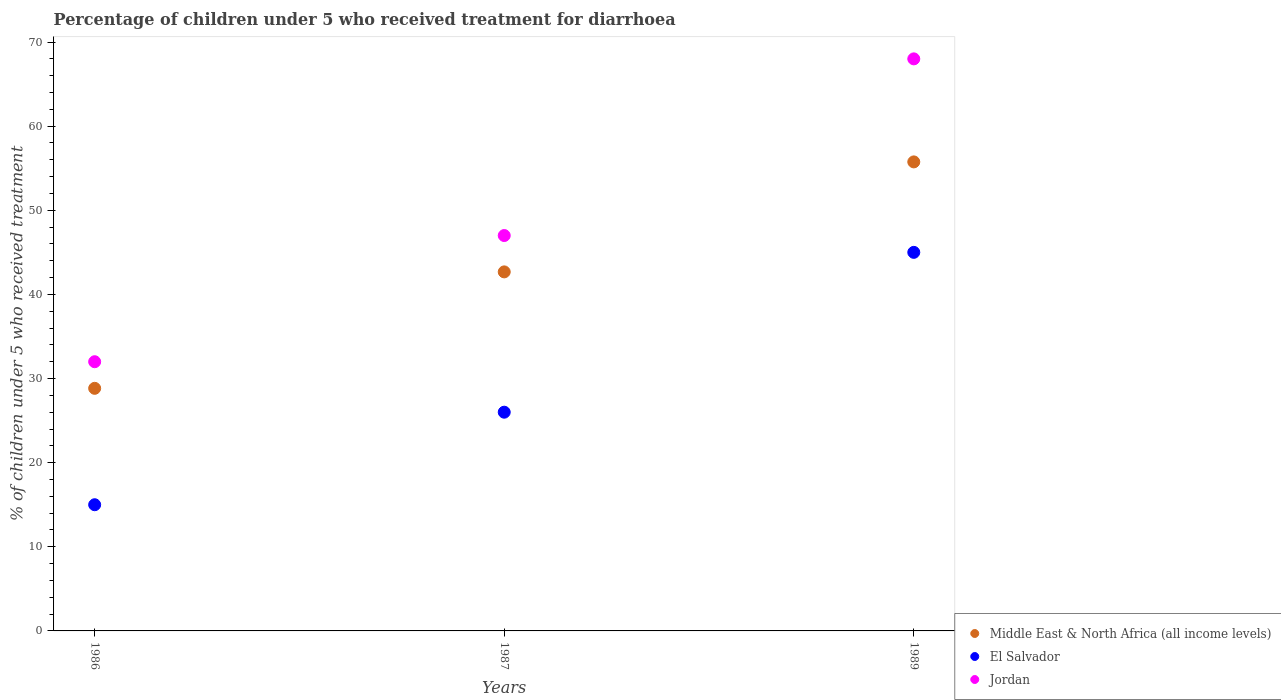What is the percentage of children who received treatment for diarrhoea  in Jordan in 1987?
Ensure brevity in your answer.  47. Across all years, what is the maximum percentage of children who received treatment for diarrhoea  in Jordan?
Your response must be concise. 68. Across all years, what is the minimum percentage of children who received treatment for diarrhoea  in Middle East & North Africa (all income levels)?
Ensure brevity in your answer.  28.84. In which year was the percentage of children who received treatment for diarrhoea  in Middle East & North Africa (all income levels) minimum?
Provide a short and direct response. 1986. What is the total percentage of children who received treatment for diarrhoea  in Middle East & North Africa (all income levels) in the graph?
Keep it short and to the point. 127.27. What is the difference between the percentage of children who received treatment for diarrhoea  in Middle East & North Africa (all income levels) in 1987 and that in 1989?
Provide a succinct answer. -13.07. What is the average percentage of children who received treatment for diarrhoea  in El Salvador per year?
Give a very brief answer. 28.67. In the year 1987, what is the difference between the percentage of children who received treatment for diarrhoea  in El Salvador and percentage of children who received treatment for diarrhoea  in Jordan?
Give a very brief answer. -21. What is the ratio of the percentage of children who received treatment for diarrhoea  in Middle East & North Africa (all income levels) in 1987 to that in 1989?
Your answer should be compact. 0.77. What is the difference between the highest and the second highest percentage of children who received treatment for diarrhoea  in Middle East & North Africa (all income levels)?
Your answer should be very brief. 13.07. What is the difference between the highest and the lowest percentage of children who received treatment for diarrhoea  in Middle East & North Africa (all income levels)?
Give a very brief answer. 26.92. In how many years, is the percentage of children who received treatment for diarrhoea  in El Salvador greater than the average percentage of children who received treatment for diarrhoea  in El Salvador taken over all years?
Your answer should be very brief. 1. Is it the case that in every year, the sum of the percentage of children who received treatment for diarrhoea  in Middle East & North Africa (all income levels) and percentage of children who received treatment for diarrhoea  in El Salvador  is greater than the percentage of children who received treatment for diarrhoea  in Jordan?
Ensure brevity in your answer.  Yes. Does the percentage of children who received treatment for diarrhoea  in Middle East & North Africa (all income levels) monotonically increase over the years?
Your answer should be compact. Yes. Is the percentage of children who received treatment for diarrhoea  in Jordan strictly greater than the percentage of children who received treatment for diarrhoea  in Middle East & North Africa (all income levels) over the years?
Your answer should be compact. Yes. Is the percentage of children who received treatment for diarrhoea  in El Salvador strictly less than the percentage of children who received treatment for diarrhoea  in Jordan over the years?
Offer a very short reply. Yes. Are the values on the major ticks of Y-axis written in scientific E-notation?
Your response must be concise. No. Does the graph contain any zero values?
Provide a short and direct response. No. How many legend labels are there?
Make the answer very short. 3. How are the legend labels stacked?
Provide a short and direct response. Vertical. What is the title of the graph?
Your answer should be very brief. Percentage of children under 5 who received treatment for diarrhoea. What is the label or title of the X-axis?
Offer a very short reply. Years. What is the label or title of the Y-axis?
Offer a terse response. % of children under 5 who received treatment. What is the % of children under 5 who received treatment of Middle East & North Africa (all income levels) in 1986?
Provide a short and direct response. 28.84. What is the % of children under 5 who received treatment in El Salvador in 1986?
Offer a very short reply. 15. What is the % of children under 5 who received treatment of Jordan in 1986?
Provide a succinct answer. 32. What is the % of children under 5 who received treatment of Middle East & North Africa (all income levels) in 1987?
Offer a very short reply. 42.68. What is the % of children under 5 who received treatment of El Salvador in 1987?
Your response must be concise. 26. What is the % of children under 5 who received treatment in Jordan in 1987?
Offer a very short reply. 47. What is the % of children under 5 who received treatment in Middle East & North Africa (all income levels) in 1989?
Offer a very short reply. 55.75. What is the % of children under 5 who received treatment of El Salvador in 1989?
Provide a succinct answer. 45. What is the % of children under 5 who received treatment of Jordan in 1989?
Make the answer very short. 68. Across all years, what is the maximum % of children under 5 who received treatment of Middle East & North Africa (all income levels)?
Your answer should be very brief. 55.75. Across all years, what is the maximum % of children under 5 who received treatment in Jordan?
Offer a very short reply. 68. Across all years, what is the minimum % of children under 5 who received treatment in Middle East & North Africa (all income levels)?
Keep it short and to the point. 28.84. Across all years, what is the minimum % of children under 5 who received treatment of El Salvador?
Ensure brevity in your answer.  15. Across all years, what is the minimum % of children under 5 who received treatment in Jordan?
Offer a very short reply. 32. What is the total % of children under 5 who received treatment of Middle East & North Africa (all income levels) in the graph?
Provide a succinct answer. 127.27. What is the total % of children under 5 who received treatment in Jordan in the graph?
Give a very brief answer. 147. What is the difference between the % of children under 5 who received treatment in Middle East & North Africa (all income levels) in 1986 and that in 1987?
Your answer should be very brief. -13.84. What is the difference between the % of children under 5 who received treatment in El Salvador in 1986 and that in 1987?
Offer a terse response. -11. What is the difference between the % of children under 5 who received treatment in Middle East & North Africa (all income levels) in 1986 and that in 1989?
Your response must be concise. -26.92. What is the difference between the % of children under 5 who received treatment in Jordan in 1986 and that in 1989?
Your answer should be compact. -36. What is the difference between the % of children under 5 who received treatment in Middle East & North Africa (all income levels) in 1987 and that in 1989?
Make the answer very short. -13.07. What is the difference between the % of children under 5 who received treatment in El Salvador in 1987 and that in 1989?
Keep it short and to the point. -19. What is the difference between the % of children under 5 who received treatment of Middle East & North Africa (all income levels) in 1986 and the % of children under 5 who received treatment of El Salvador in 1987?
Offer a terse response. 2.84. What is the difference between the % of children under 5 who received treatment in Middle East & North Africa (all income levels) in 1986 and the % of children under 5 who received treatment in Jordan in 1987?
Your response must be concise. -18.16. What is the difference between the % of children under 5 who received treatment of El Salvador in 1986 and the % of children under 5 who received treatment of Jordan in 1987?
Ensure brevity in your answer.  -32. What is the difference between the % of children under 5 who received treatment of Middle East & North Africa (all income levels) in 1986 and the % of children under 5 who received treatment of El Salvador in 1989?
Your answer should be very brief. -16.16. What is the difference between the % of children under 5 who received treatment in Middle East & North Africa (all income levels) in 1986 and the % of children under 5 who received treatment in Jordan in 1989?
Ensure brevity in your answer.  -39.16. What is the difference between the % of children under 5 who received treatment of El Salvador in 1986 and the % of children under 5 who received treatment of Jordan in 1989?
Provide a succinct answer. -53. What is the difference between the % of children under 5 who received treatment in Middle East & North Africa (all income levels) in 1987 and the % of children under 5 who received treatment in El Salvador in 1989?
Offer a very short reply. -2.32. What is the difference between the % of children under 5 who received treatment of Middle East & North Africa (all income levels) in 1987 and the % of children under 5 who received treatment of Jordan in 1989?
Make the answer very short. -25.32. What is the difference between the % of children under 5 who received treatment in El Salvador in 1987 and the % of children under 5 who received treatment in Jordan in 1989?
Keep it short and to the point. -42. What is the average % of children under 5 who received treatment of Middle East & North Africa (all income levels) per year?
Make the answer very short. 42.42. What is the average % of children under 5 who received treatment in El Salvador per year?
Give a very brief answer. 28.67. What is the average % of children under 5 who received treatment of Jordan per year?
Give a very brief answer. 49. In the year 1986, what is the difference between the % of children under 5 who received treatment in Middle East & North Africa (all income levels) and % of children under 5 who received treatment in El Salvador?
Offer a very short reply. 13.84. In the year 1986, what is the difference between the % of children under 5 who received treatment of Middle East & North Africa (all income levels) and % of children under 5 who received treatment of Jordan?
Your answer should be compact. -3.16. In the year 1987, what is the difference between the % of children under 5 who received treatment in Middle East & North Africa (all income levels) and % of children under 5 who received treatment in El Salvador?
Make the answer very short. 16.68. In the year 1987, what is the difference between the % of children under 5 who received treatment of Middle East & North Africa (all income levels) and % of children under 5 who received treatment of Jordan?
Your response must be concise. -4.32. In the year 1987, what is the difference between the % of children under 5 who received treatment in El Salvador and % of children under 5 who received treatment in Jordan?
Keep it short and to the point. -21. In the year 1989, what is the difference between the % of children under 5 who received treatment of Middle East & North Africa (all income levels) and % of children under 5 who received treatment of El Salvador?
Make the answer very short. 10.75. In the year 1989, what is the difference between the % of children under 5 who received treatment of Middle East & North Africa (all income levels) and % of children under 5 who received treatment of Jordan?
Provide a succinct answer. -12.25. What is the ratio of the % of children under 5 who received treatment of Middle East & North Africa (all income levels) in 1986 to that in 1987?
Ensure brevity in your answer.  0.68. What is the ratio of the % of children under 5 who received treatment of El Salvador in 1986 to that in 1987?
Your response must be concise. 0.58. What is the ratio of the % of children under 5 who received treatment in Jordan in 1986 to that in 1987?
Your response must be concise. 0.68. What is the ratio of the % of children under 5 who received treatment in Middle East & North Africa (all income levels) in 1986 to that in 1989?
Your answer should be compact. 0.52. What is the ratio of the % of children under 5 who received treatment in Jordan in 1986 to that in 1989?
Give a very brief answer. 0.47. What is the ratio of the % of children under 5 who received treatment of Middle East & North Africa (all income levels) in 1987 to that in 1989?
Your answer should be very brief. 0.77. What is the ratio of the % of children under 5 who received treatment in El Salvador in 1987 to that in 1989?
Your answer should be very brief. 0.58. What is the ratio of the % of children under 5 who received treatment of Jordan in 1987 to that in 1989?
Make the answer very short. 0.69. What is the difference between the highest and the second highest % of children under 5 who received treatment in Middle East & North Africa (all income levels)?
Give a very brief answer. 13.07. What is the difference between the highest and the lowest % of children under 5 who received treatment in Middle East & North Africa (all income levels)?
Your response must be concise. 26.92. What is the difference between the highest and the lowest % of children under 5 who received treatment of El Salvador?
Keep it short and to the point. 30. 